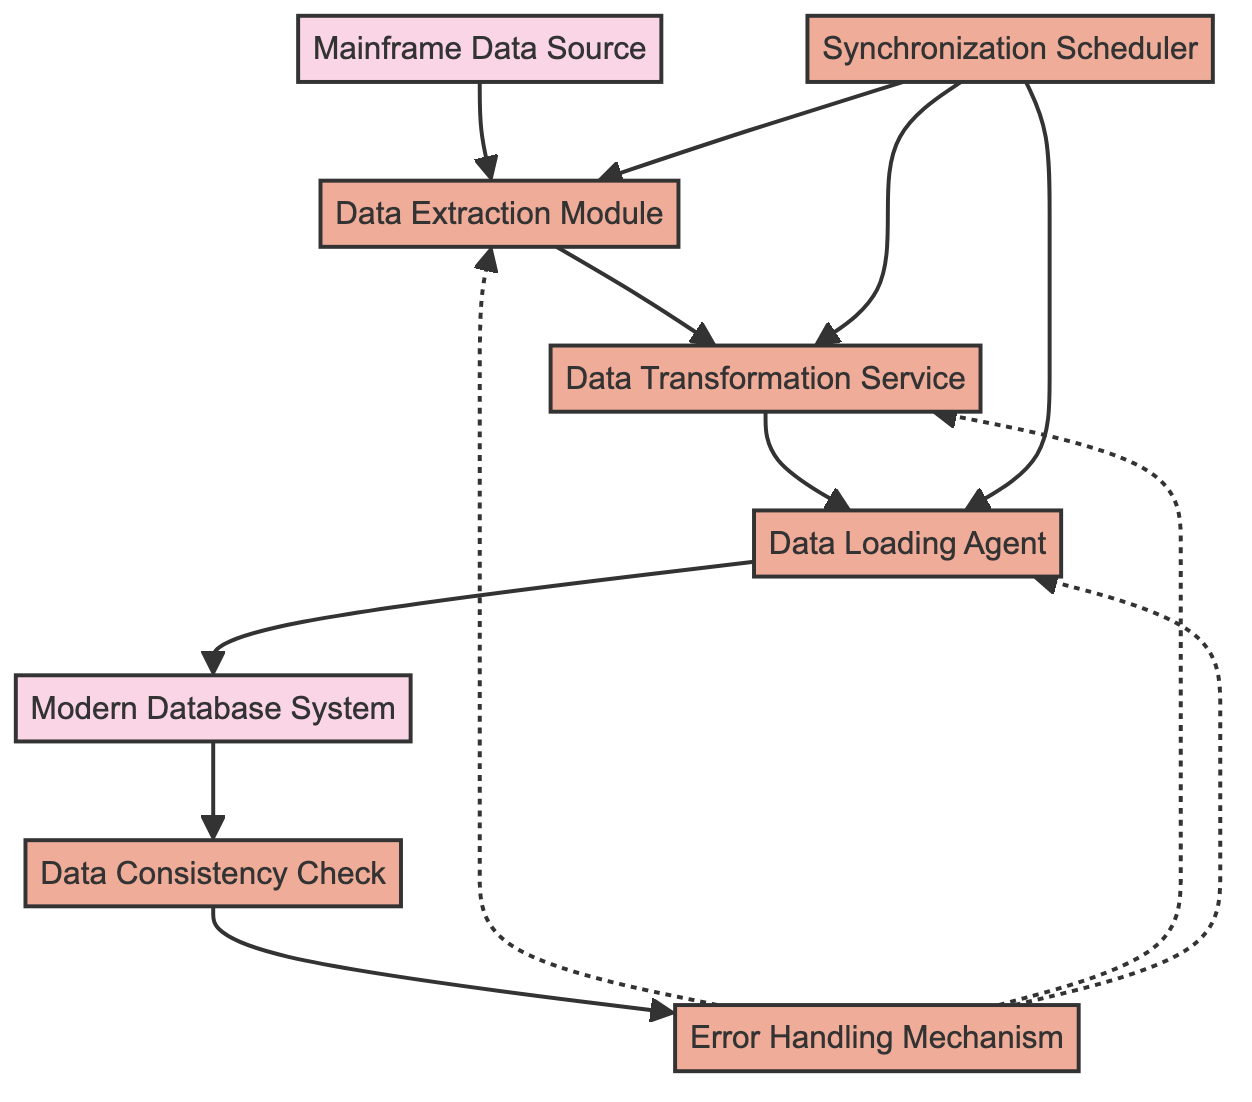What is the first node in the process? The first node in the flow chart is labeled "Mainframe Data Source," which is the starting point of the data synchronization process.
Answer: Mainframe Data Source How many process nodes are there in the diagram? There are a total of five process nodes: Data Extraction Module, Data Transformation Service, Data Loading Agent, Data Consistency Check, and Error Handling Mechanism.
Answer: Five Which node follows the "Data Extraction Module"? The node that follows "Data Extraction Module" is "Data Transformation Service," indicating that after data extraction, data transformation occurs next.
Answer: Data Transformation Service What is the role of the "Synchronization Scheduler"? The "Synchronization Scheduler" is responsible for managing the timing and frequency of synchronization tasks, ensuring the process occurs at designated intervals.
Answer: Scheduler How are errors handled in this synchronization process? Errors are handled by the "Error Handling Mechanism," which logs and resolves any issues encountered during the synchronization process.
Answer: Error Handling Mechanism Which process verifies data integrity after synchronization? The "Data Consistency Check" process is responsible for verifying data integrity after the synchronization has taken place, ensuring the data remains accurate and reliable.
Answer: Data Consistency Check Which two nodes are connected with a dashed line? The nodes connected with a dashed line are "Error Handling Mechanism" and "Data Extraction Module," indicating an error flow from the error handling mechanism back to the extraction process.
Answer: Error Handling Mechanism and Data Extraction Module What is the relationship between "Modern Database System" and the "Data Loading Agent"? The "Data Loading Agent" loads the transformed data directly into the "Modern Database System," establishing a direct dependency where the agent acts on the database.
Answer: Loads into Which processes does the "Synchronization Scheduler" manage? The "Synchronization Scheduler" manages the Data Extraction Module, Data Transformation Service, and Data Loading Agent, coordinating their execution for synchronization.
Answer: Three processes: Data Extraction Module, Data Transformation Service, Data Loading Agent What can be inferred about the process order from this diagram? The diagram indicates a sequential process order starting from the mainframe data source through extraction, transformation, loading, and finally checking data consistency, with error handling integrated throughout.
Answer: Sequential process order 